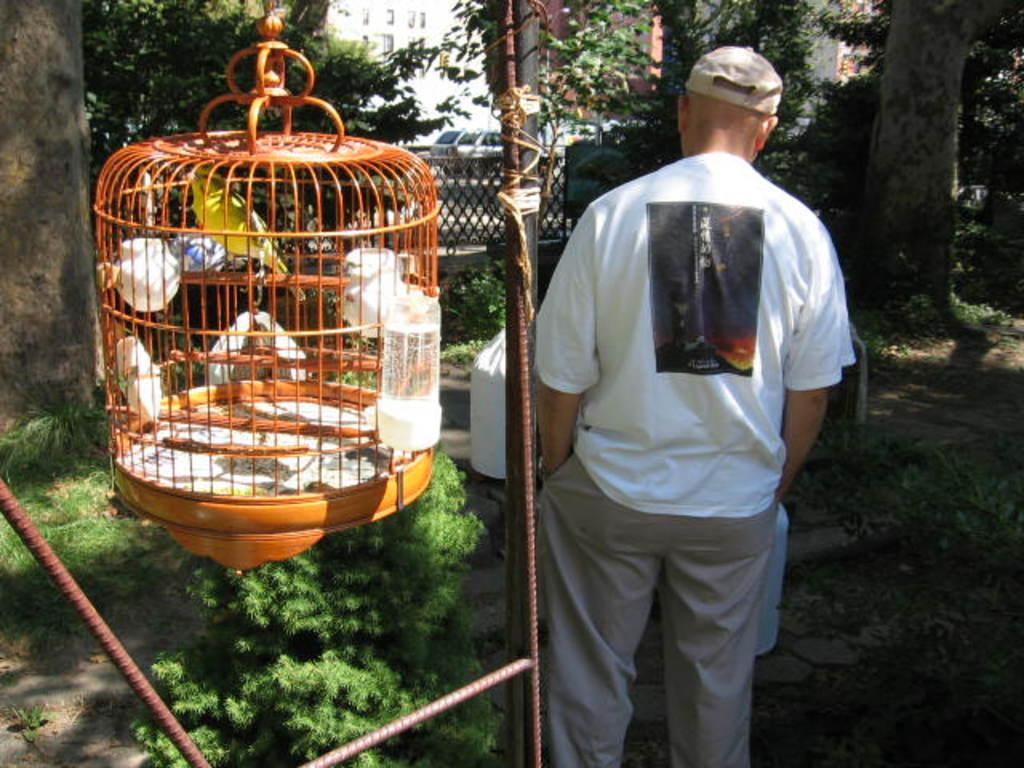Could you give a brief overview of what you see in this image? In this image I can see few metal rods and a bird cage which is brown in color. I can see a bird which is yellow in color in the cage. I can see few trees and a person standing. In the background I can see few vehicles and few buildings. 